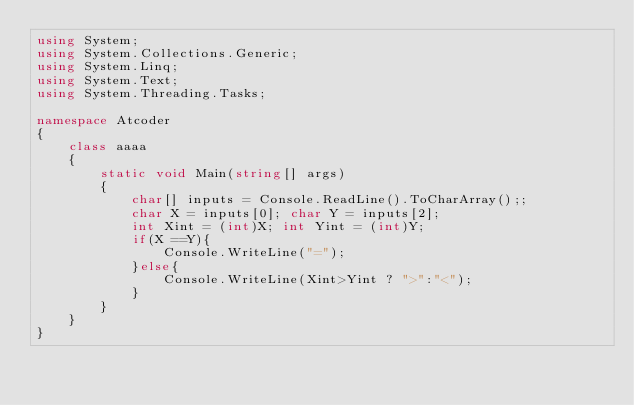Convert code to text. <code><loc_0><loc_0><loc_500><loc_500><_C#_>using System;
using System.Collections.Generic;
using System.Linq;
using System.Text;
using System.Threading.Tasks;
 
namespace Atcoder
{
    class aaaa
    {
        static void Main(string[] args)
        {
            char[] inputs = Console.ReadLine().ToCharArray();;
            char X = inputs[0]; char Y = inputs[2];
            int Xint = (int)X; int Yint = (int)Y;
            if(X ==Y){
                Console.WriteLine("=");
            }else{
                Console.WriteLine(Xint>Yint ? ">":"<");
            }
        }
    }
}</code> 